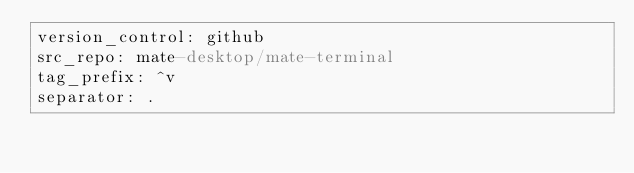Convert code to text. <code><loc_0><loc_0><loc_500><loc_500><_YAML_>version_control: github
src_repo: mate-desktop/mate-terminal
tag_prefix: ^v
separator: .</code> 